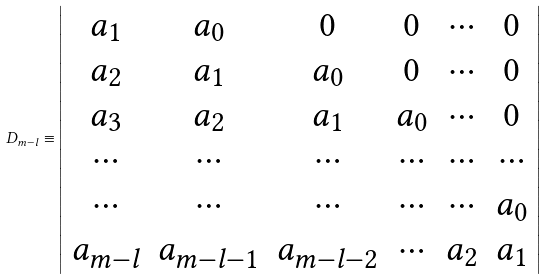Convert formula to latex. <formula><loc_0><loc_0><loc_500><loc_500>D _ { m - l } \equiv \left | \begin{array} { c c c c c c } a _ { 1 } & a _ { 0 } & 0 & 0 & \cdots & 0 \\ a _ { 2 } & a _ { 1 } & a _ { 0 } & 0 & \cdots & 0 \\ a _ { 3 } & a _ { 2 } & a _ { 1 } & a _ { 0 } & \cdots & 0 \\ \cdots & \cdots & \cdots & \cdots & \cdots & \cdots \\ \cdots & \cdots & \cdots & \cdots & \cdots & a _ { 0 } \\ a _ { m - l } & a _ { m - l - 1 } & a _ { m - l - 2 } & \cdots & a _ { 2 } & a _ { 1 } \end{array} \right |</formula> 